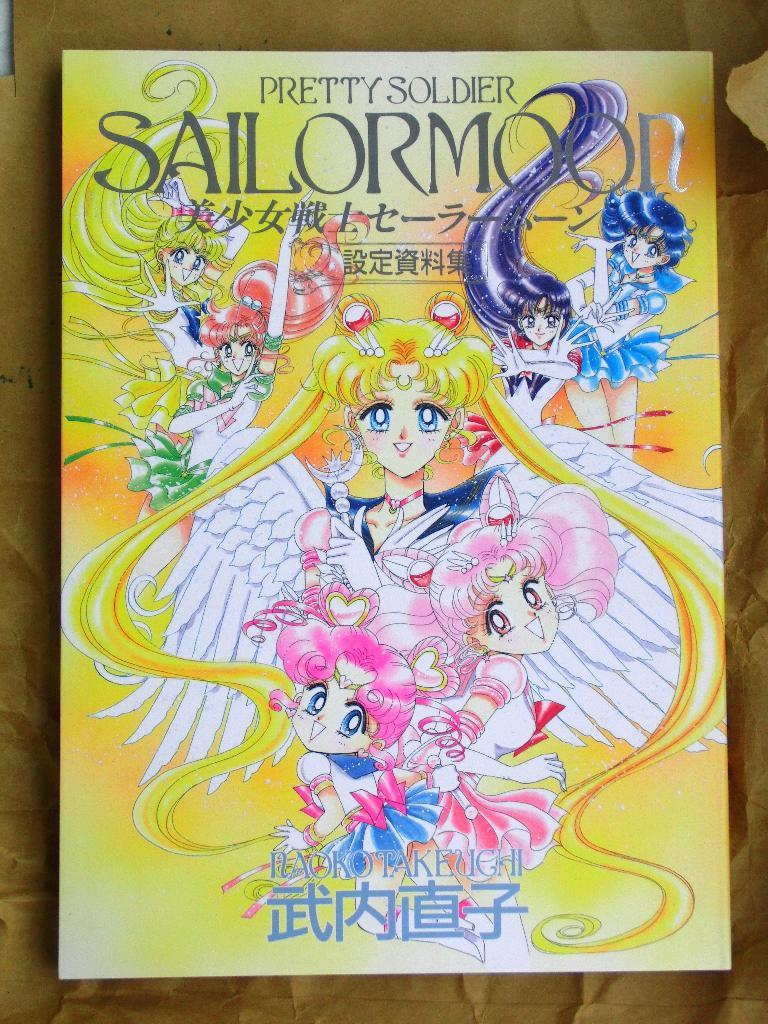What is the title?
Offer a terse response. Pretty soldier sailormoon. 